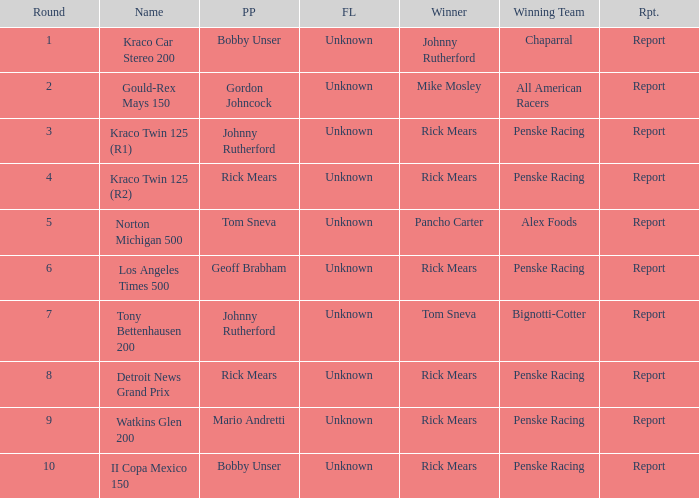The winning team of the race, los angeles times 500 is who? Penske Racing. Write the full table. {'header': ['Round', 'Name', 'PP', 'FL', 'Winner', 'Winning Team', 'Rpt.'], 'rows': [['1', 'Kraco Car Stereo 200', 'Bobby Unser', 'Unknown', 'Johnny Rutherford', 'Chaparral', 'Report'], ['2', 'Gould-Rex Mays 150', 'Gordon Johncock', 'Unknown', 'Mike Mosley', 'All American Racers', 'Report'], ['3', 'Kraco Twin 125 (R1)', 'Johnny Rutherford', 'Unknown', 'Rick Mears', 'Penske Racing', 'Report'], ['4', 'Kraco Twin 125 (R2)', 'Rick Mears', 'Unknown', 'Rick Mears', 'Penske Racing', 'Report'], ['5', 'Norton Michigan 500', 'Tom Sneva', 'Unknown', 'Pancho Carter', 'Alex Foods', 'Report'], ['6', 'Los Angeles Times 500', 'Geoff Brabham', 'Unknown', 'Rick Mears', 'Penske Racing', 'Report'], ['7', 'Tony Bettenhausen 200', 'Johnny Rutherford', 'Unknown', 'Tom Sneva', 'Bignotti-Cotter', 'Report'], ['8', 'Detroit News Grand Prix', 'Rick Mears', 'Unknown', 'Rick Mears', 'Penske Racing', 'Report'], ['9', 'Watkins Glen 200', 'Mario Andretti', 'Unknown', 'Rick Mears', 'Penske Racing', 'Report'], ['10', 'II Copa Mexico 150', 'Bobby Unser', 'Unknown', 'Rick Mears', 'Penske Racing', 'Report']]} 